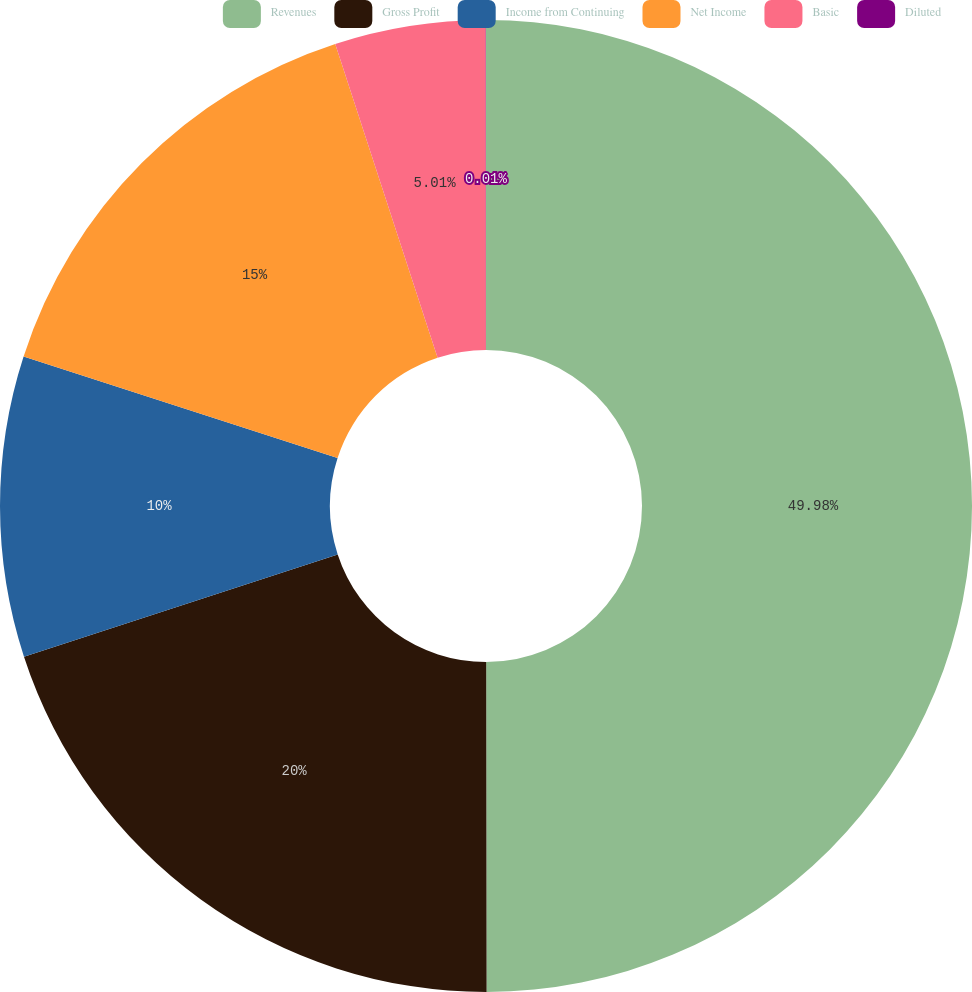Convert chart to OTSL. <chart><loc_0><loc_0><loc_500><loc_500><pie_chart><fcel>Revenues<fcel>Gross Profit<fcel>Income from Continuing<fcel>Net Income<fcel>Basic<fcel>Diluted<nl><fcel>49.98%<fcel>20.0%<fcel>10.0%<fcel>15.0%<fcel>5.01%<fcel>0.01%<nl></chart> 